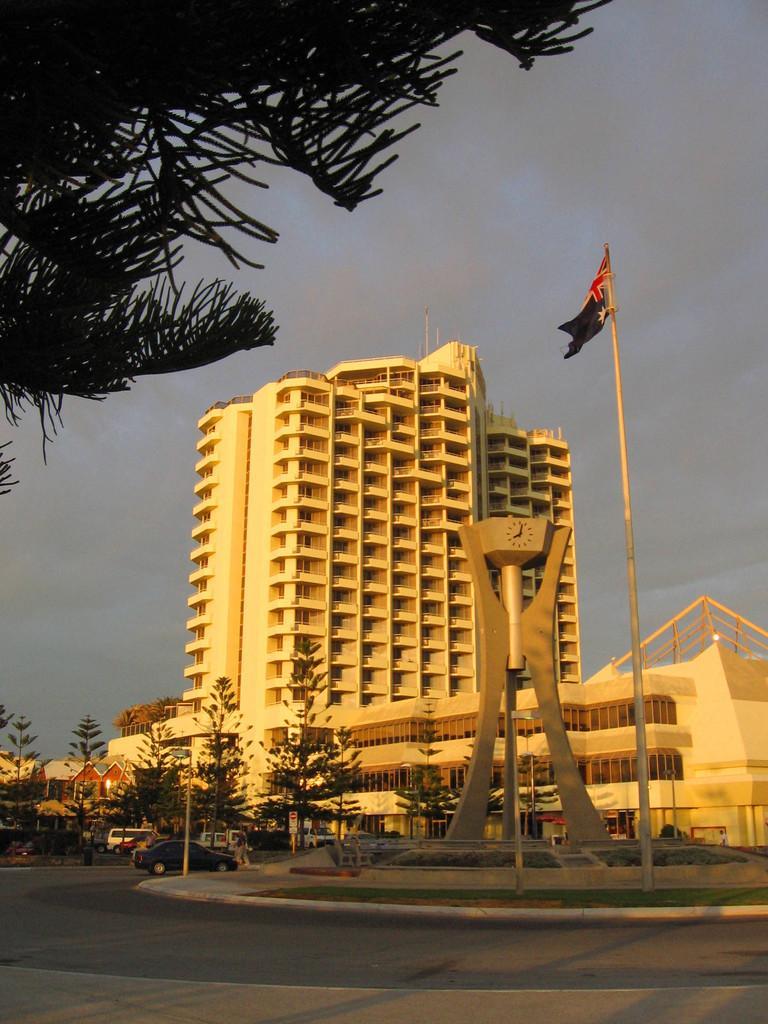Could you give a brief overview of what you see in this image? In the center of the image, we can see a monument and a flag and in the background, there is a building and we can see trees and poles and there is a board and we can see some vehicles on the road. At the top, there is sky. 